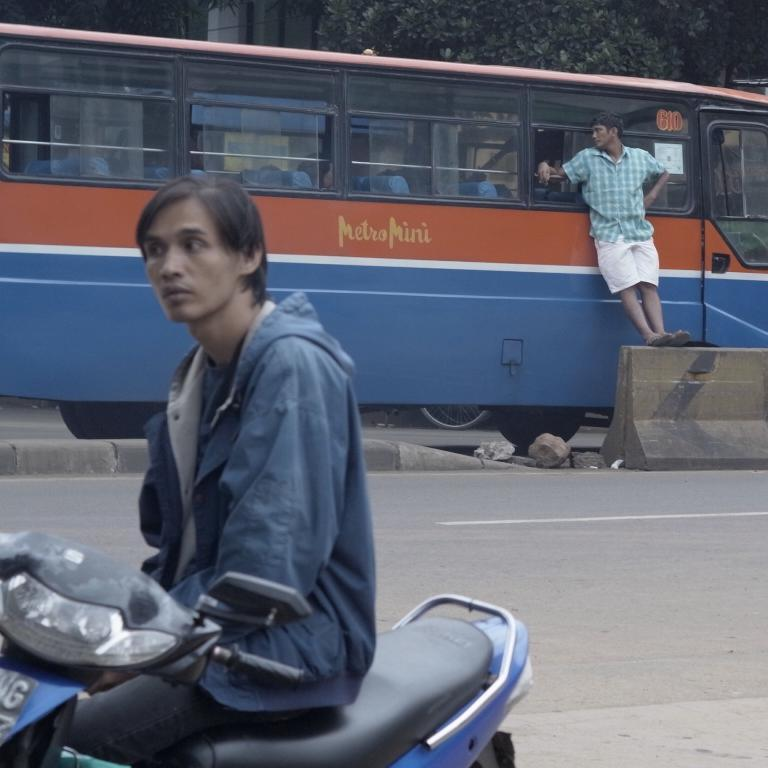What is the main subject of the image? There is a vehicle on the road in the image. Can you describe the actions of the people in the image? One person is standing on the divider, and there is a person with a bike on the other side of the road. What type of cookware is being used by the cook in the image? There is no cook or cookware present in the image. How many corks are visible in the image? There are no corks visible in the image. 